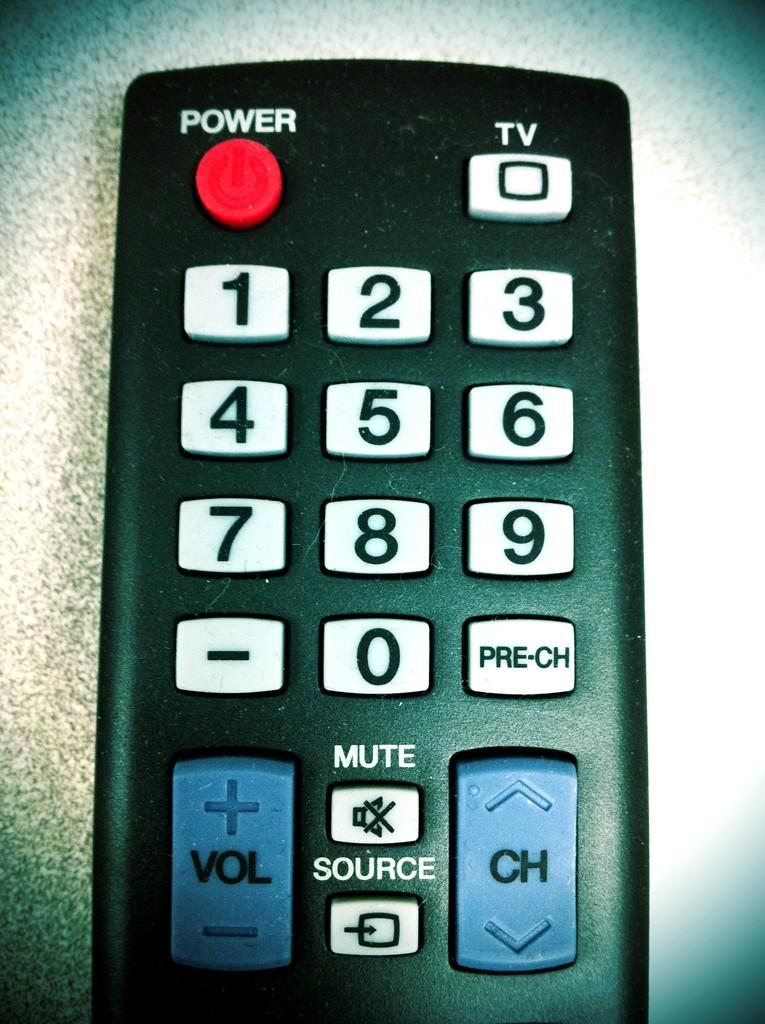Provide a one-sentence caption for the provided image. a black remote control to a television with white keys and blue volume and channel buttons. 